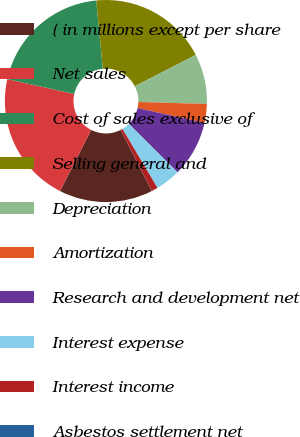Convert chart. <chart><loc_0><loc_0><loc_500><loc_500><pie_chart><fcel>( in millions except per share<fcel>Net sales<fcel>Cost of sales exclusive of<fcel>Selling general and<fcel>Depreciation<fcel>Amortization<fcel>Research and development net<fcel>Interest expense<fcel>Interest income<fcel>Asbestos settlement net<nl><fcel>15.0%<fcel>20.99%<fcel>19.99%<fcel>18.99%<fcel>8.0%<fcel>3.01%<fcel>9.0%<fcel>4.0%<fcel>1.01%<fcel>0.01%<nl></chart> 